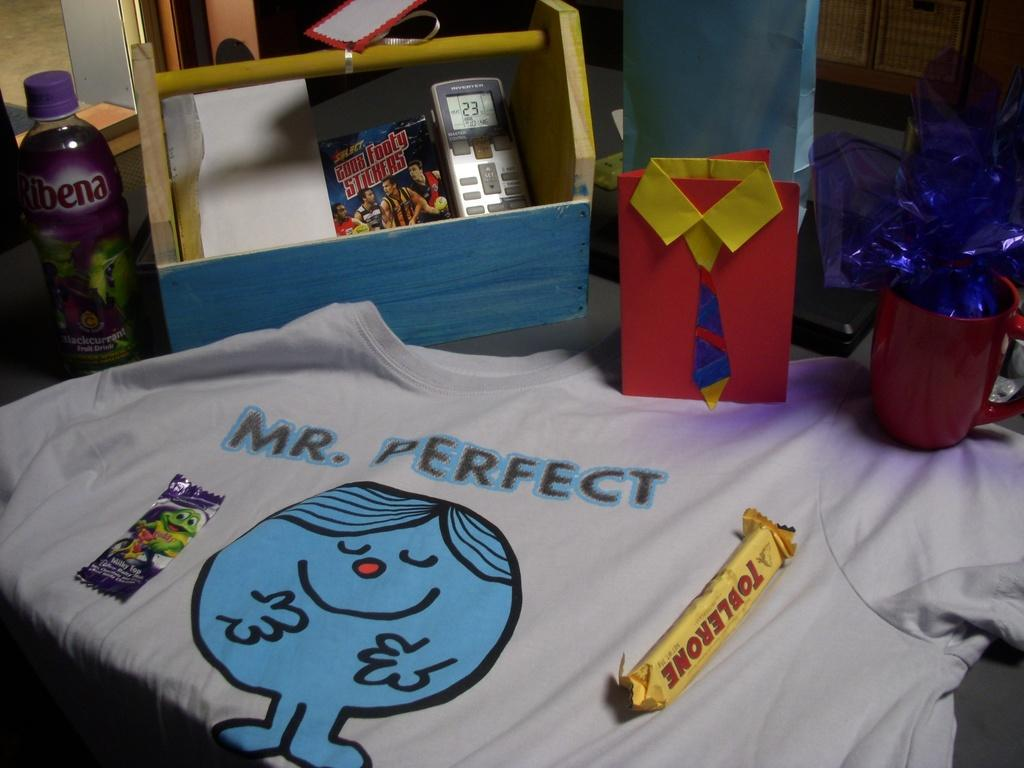Provide a one-sentence caption for the provided image. Mrs. Perfect is written on a shirt next to a Toblerone candy bar. 